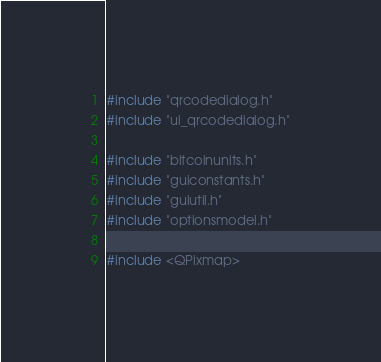<code> <loc_0><loc_0><loc_500><loc_500><_C++_>#include "qrcodedialog.h"
#include "ui_qrcodedialog.h"

#include "bitcoinunits.h"
#include "guiconstants.h"
#include "guiutil.h"
#include "optionsmodel.h"

#include <QPixmap></code> 